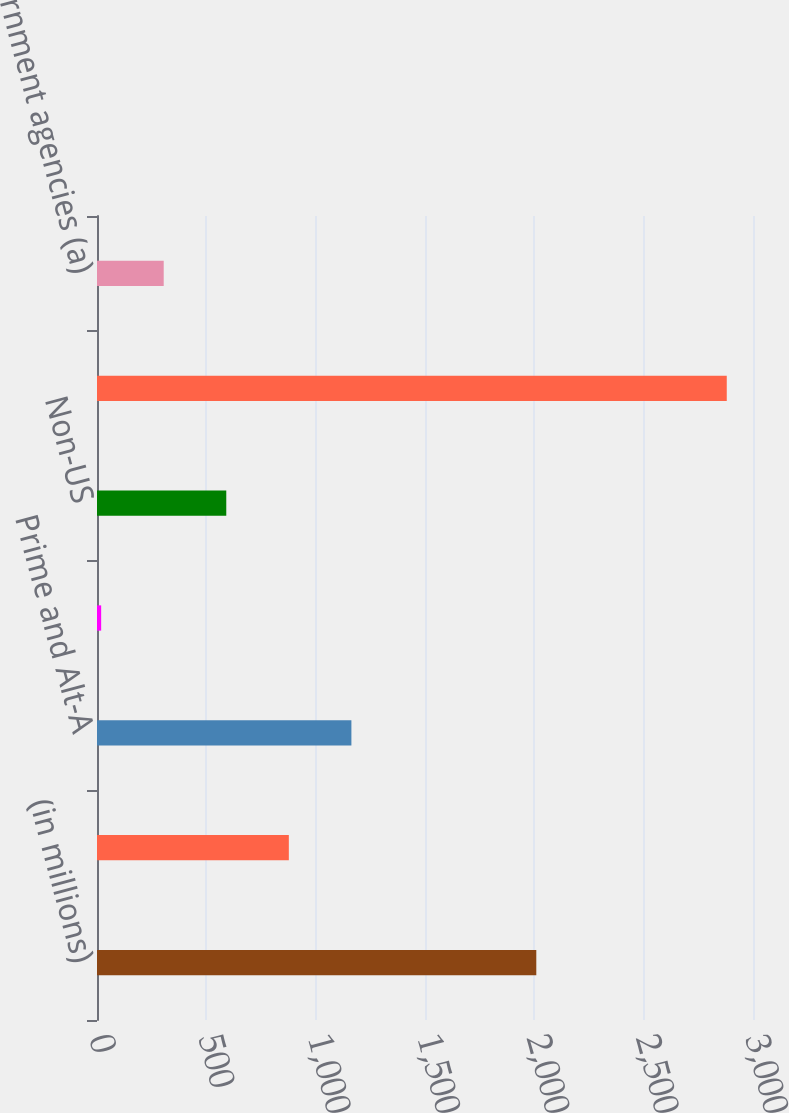Convert chart. <chart><loc_0><loc_0><loc_500><loc_500><bar_chart><fcel>(in millions)<fcel>US government agencies<fcel>Prime and Alt-A<fcel>Subprime<fcel>Non-US<fcel>Total mortgage-backed<fcel>US government agencies (a)<nl><fcel>2009<fcel>877.3<fcel>1163.4<fcel>19<fcel>591.2<fcel>2880<fcel>305.1<nl></chart> 